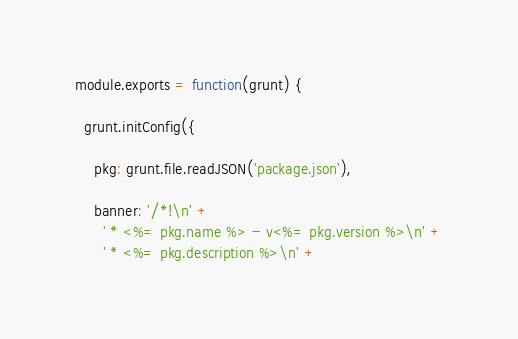<code> <loc_0><loc_0><loc_500><loc_500><_JavaScript_>module.exports = function(grunt) {

  grunt.initConfig({

    pkg: grunt.file.readJSON('package.json'),

    banner: '/*!\n' +
      ' * <%= pkg.name %> - v<%= pkg.version %>\n' +
      ' * <%= pkg.description %>\n' +</code> 